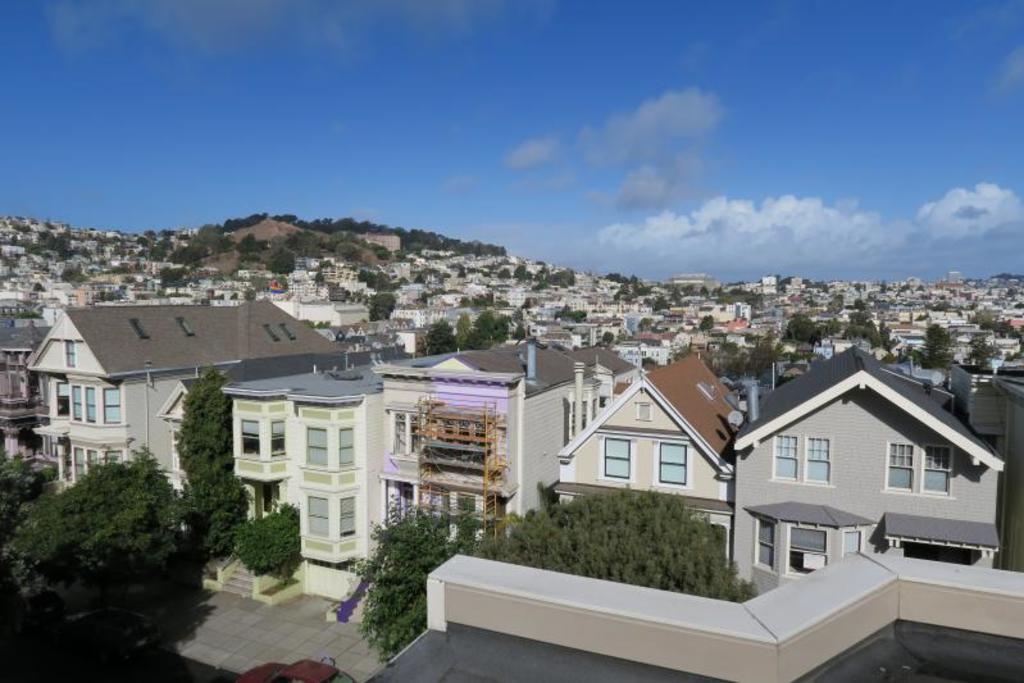Please provide a concise description of this image. In this picture I can observe some buildings. There are trees in between the buildings. I can observe some clouds in the sky. 